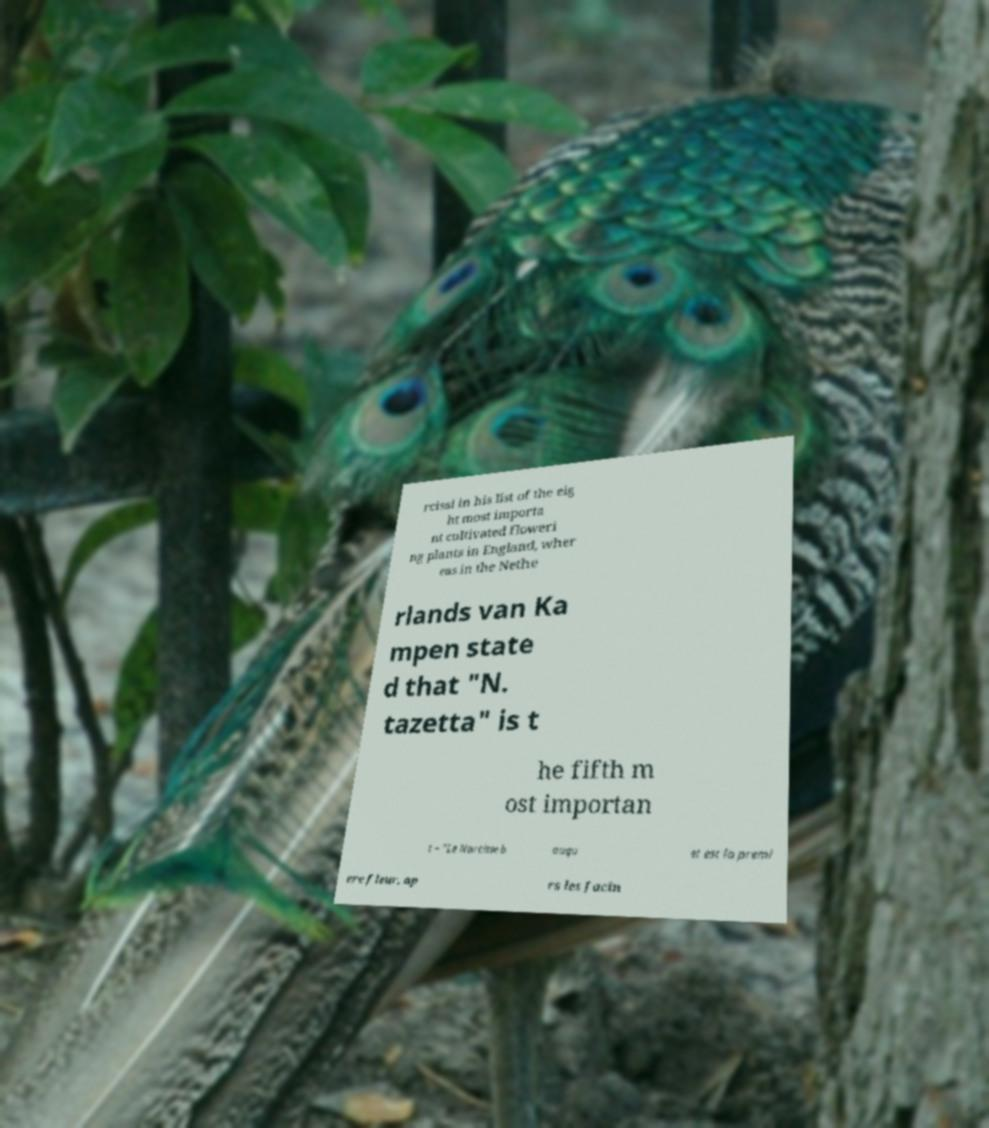What messages or text are displayed in this image? I need them in a readable, typed format. rcissi in his list of the eig ht most importa nt cultivated floweri ng plants in England, wher eas in the Nethe rlands van Ka mpen state d that "N. tazetta" is t he fifth m ost importan t – "Le Narcisse b ouqu et est la premi ere fleur, ap rs les Jacin 